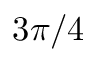Convert formula to latex. <formula><loc_0><loc_0><loc_500><loc_500>3 \pi / 4</formula> 